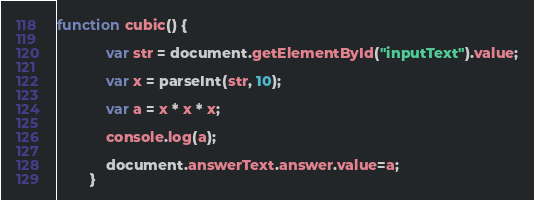<code> <loc_0><loc_0><loc_500><loc_500><_JavaScript_>function cubic() {
			
			var str = document.getElementById("inputText").value;
			
			var x = parseInt(str, 10);
			
			var a = x * x * x;
			
			console.log(a);
			
			document.answerText.answer.value=a;
		}</code> 